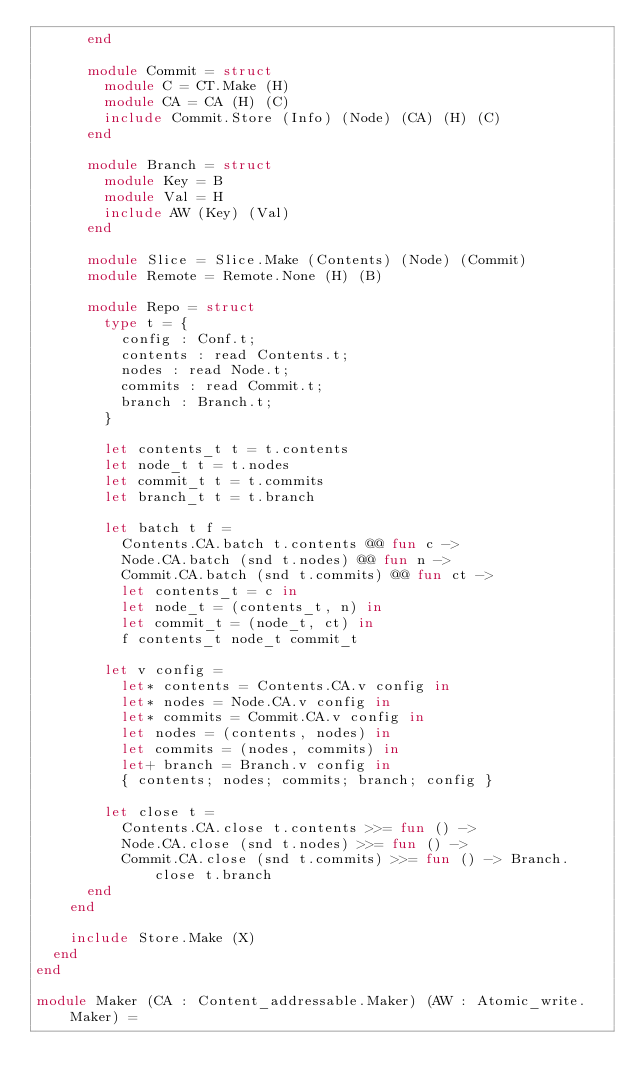<code> <loc_0><loc_0><loc_500><loc_500><_OCaml_>      end

      module Commit = struct
        module C = CT.Make (H)
        module CA = CA (H) (C)
        include Commit.Store (Info) (Node) (CA) (H) (C)
      end

      module Branch = struct
        module Key = B
        module Val = H
        include AW (Key) (Val)
      end

      module Slice = Slice.Make (Contents) (Node) (Commit)
      module Remote = Remote.None (H) (B)

      module Repo = struct
        type t = {
          config : Conf.t;
          contents : read Contents.t;
          nodes : read Node.t;
          commits : read Commit.t;
          branch : Branch.t;
        }

        let contents_t t = t.contents
        let node_t t = t.nodes
        let commit_t t = t.commits
        let branch_t t = t.branch

        let batch t f =
          Contents.CA.batch t.contents @@ fun c ->
          Node.CA.batch (snd t.nodes) @@ fun n ->
          Commit.CA.batch (snd t.commits) @@ fun ct ->
          let contents_t = c in
          let node_t = (contents_t, n) in
          let commit_t = (node_t, ct) in
          f contents_t node_t commit_t

        let v config =
          let* contents = Contents.CA.v config in
          let* nodes = Node.CA.v config in
          let* commits = Commit.CA.v config in
          let nodes = (contents, nodes) in
          let commits = (nodes, commits) in
          let+ branch = Branch.v config in
          { contents; nodes; commits; branch; config }

        let close t =
          Contents.CA.close t.contents >>= fun () ->
          Node.CA.close (snd t.nodes) >>= fun () ->
          Commit.CA.close (snd t.commits) >>= fun () -> Branch.close t.branch
      end
    end

    include Store.Make (X)
  end
end

module Maker (CA : Content_addressable.Maker) (AW : Atomic_write.Maker) =</code> 